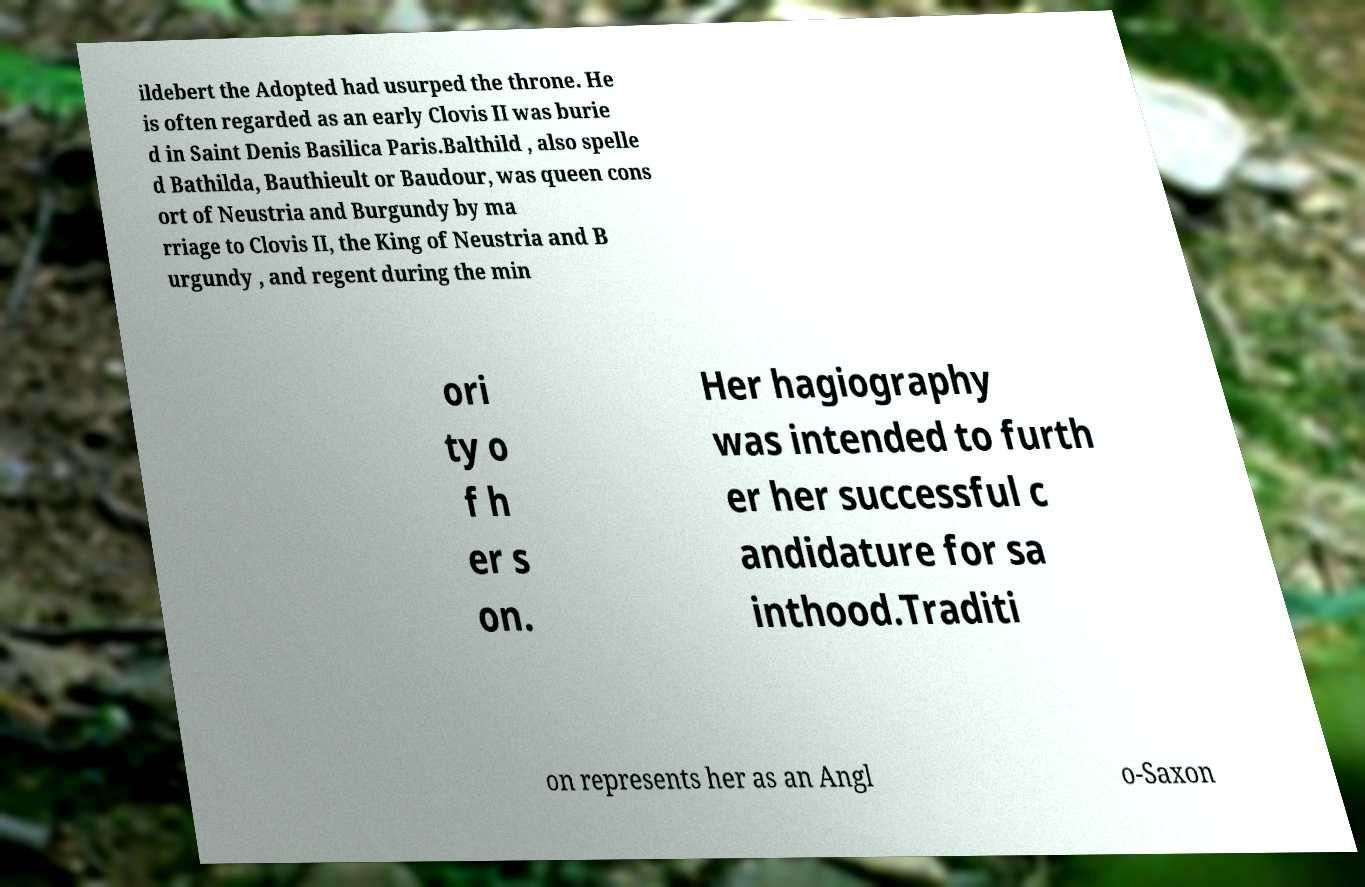I need the written content from this picture converted into text. Can you do that? ildebert the Adopted had usurped the throne. He is often regarded as an early Clovis II was burie d in Saint Denis Basilica Paris.Balthild , also spelle d Bathilda, Bauthieult or Baudour, was queen cons ort of Neustria and Burgundy by ma rriage to Clovis II, the King of Neustria and B urgundy , and regent during the min ori ty o f h er s on. Her hagiography was intended to furth er her successful c andidature for sa inthood.Traditi on represents her as an Angl o-Saxon 